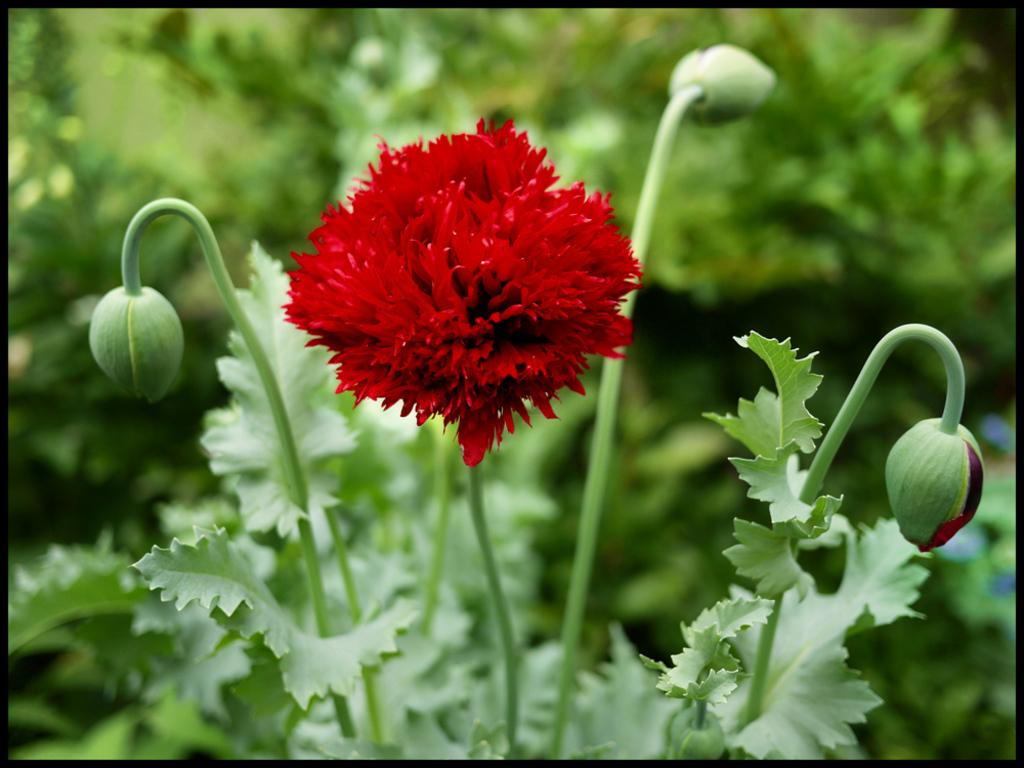What type of flower is present in the image? There is a red color flower in the image. What color are the leaves in the image? The leaves are green. How would you describe the background of the image? The background of the image is blurred. What type of produce is being harvested in the image? There is no produce being harvested in the image; it features a red flower and green leaves. Is there a volcano visible in the image? No, there is no volcano present in the image. 